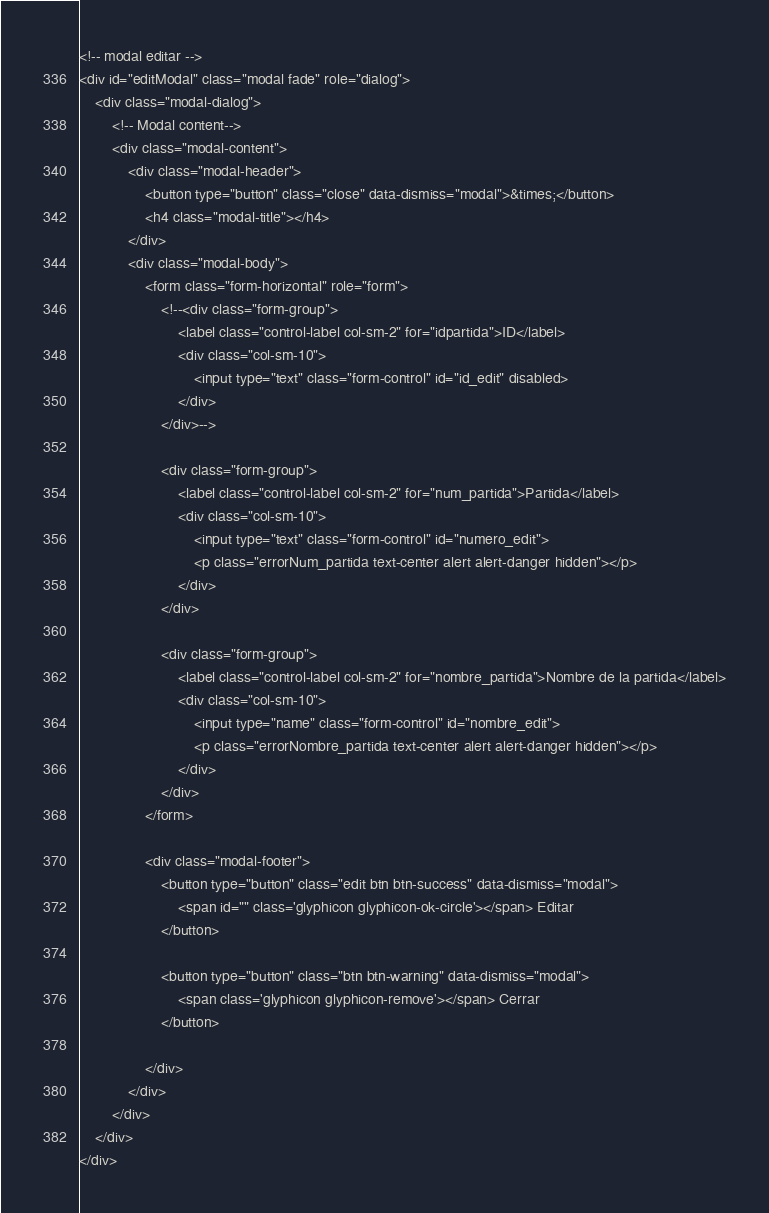Convert code to text. <code><loc_0><loc_0><loc_500><loc_500><_PHP_><!-- modal editar -->
<div id="editModal" class="modal fade" role="dialog">
    <div class="modal-dialog">
        <!-- Modal content-->
        <div class="modal-content">
            <div class="modal-header">
                <button type="button" class="close" data-dismiss="modal">&times;</button>
                <h4 class="modal-title"></h4>
            </div>
            <div class="modal-body">
                <form class="form-horizontal" role="form">
                    <!--<div class="form-group">
                        <label class="control-label col-sm-2" for="idpartida">ID</label>
                        <div class="col-sm-10">
                            <input type="text" class="form-control" id="id_edit" disabled>
                        </div>
                    </div>-->

                    <div class="form-group">
                        <label class="control-label col-sm-2" for="num_partida">Partida</label>
                        <div class="col-sm-10">
                            <input type="text" class="form-control" id="numero_edit">
                            <p class="errorNum_partida text-center alert alert-danger hidden"></p>
                        </div>
                    </div>

                    <div class="form-group">
                        <label class="control-label col-sm-2" for="nombre_partida">Nombre de la partida</label>
                        <div class="col-sm-10">
                            <input type="name" class="form-control" id="nombre_edit">
                            <p class="errorNombre_partida text-center alert alert-danger hidden"></p>
                        </div>
                    </div>
                </form>

                <div class="modal-footer">
                    <button type="button" class="edit btn btn-success" data-dismiss="modal">
                        <span id="" class='glyphicon glyphicon-ok-circle'></span> Editar
                    </button>

                    <button type="button" class="btn btn-warning" data-dismiss="modal">
                        <span class='glyphicon glyphicon-remove'></span> Cerrar
                    </button>

                </div>
            </div>
        </div>
    </div>
</div></code> 